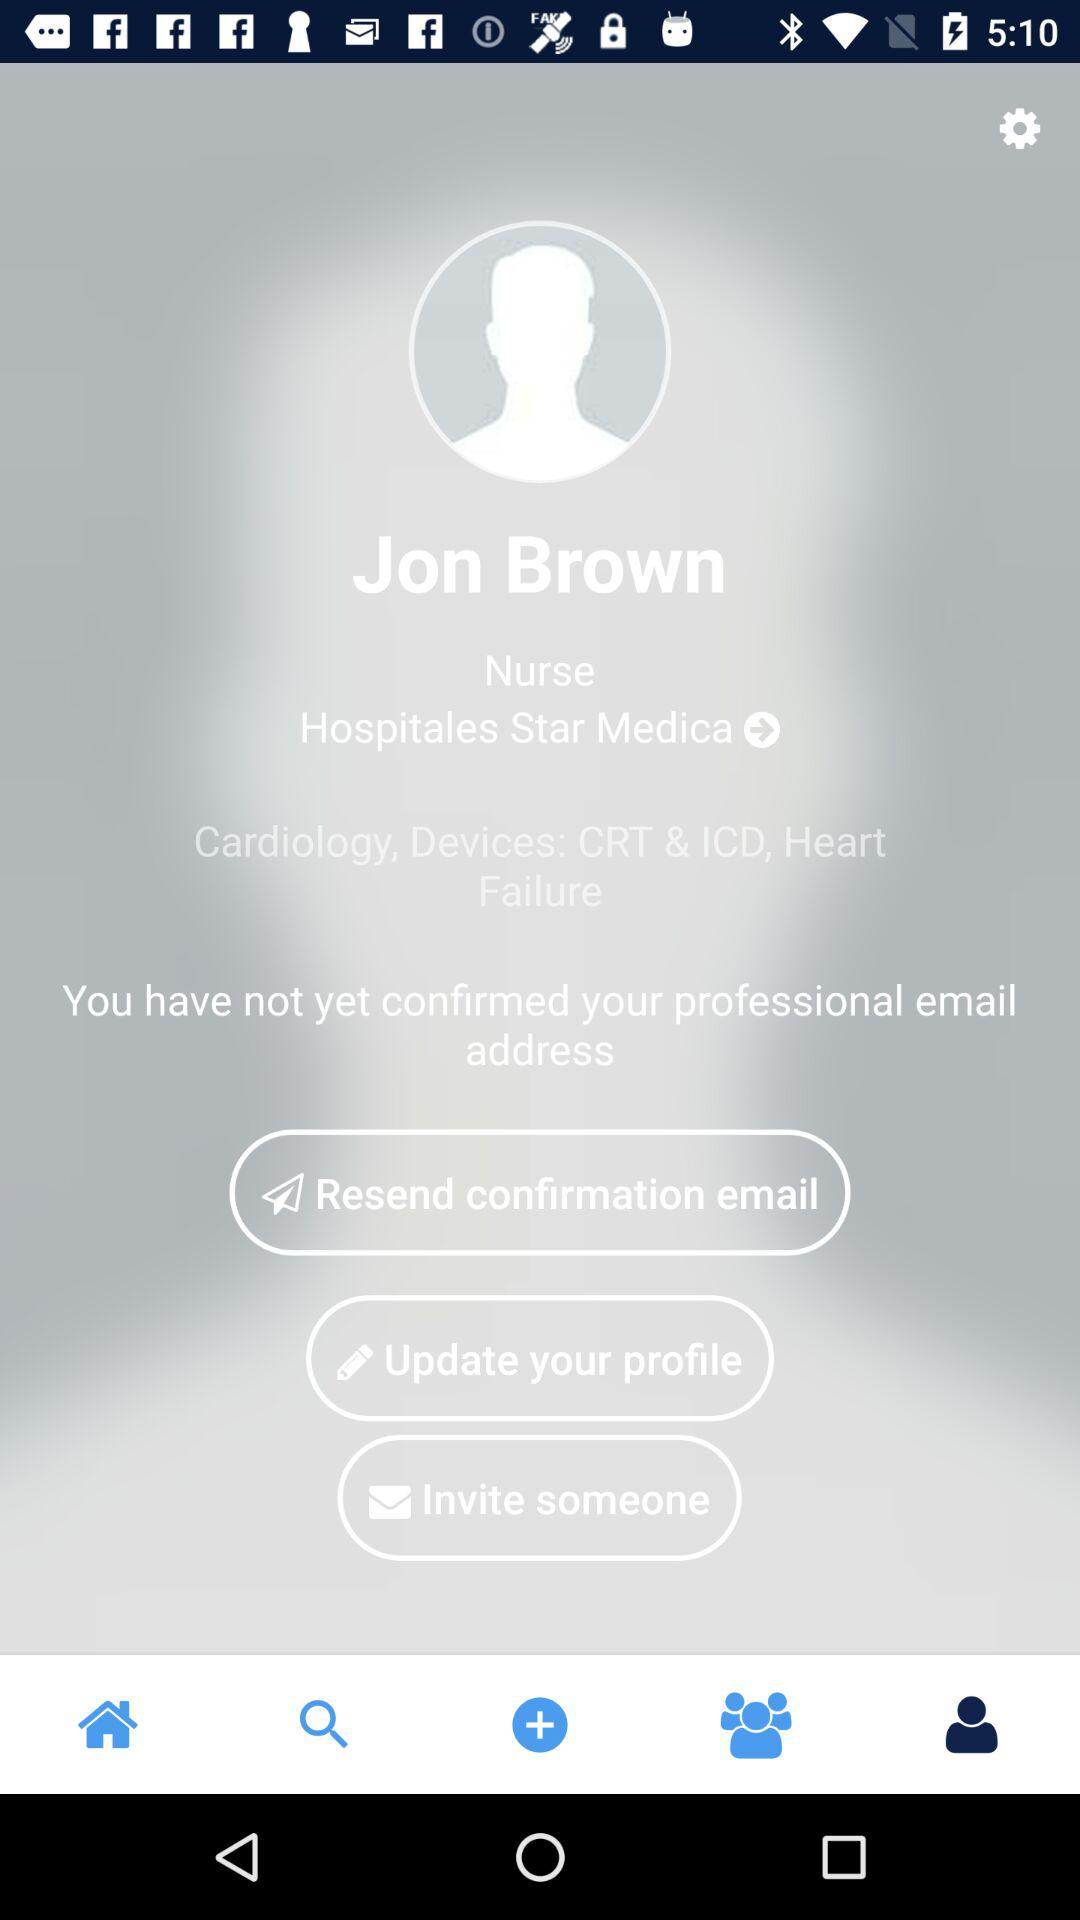How old is Jon Brown?
When the provided information is insufficient, respond with <no answer>. <no answer> 